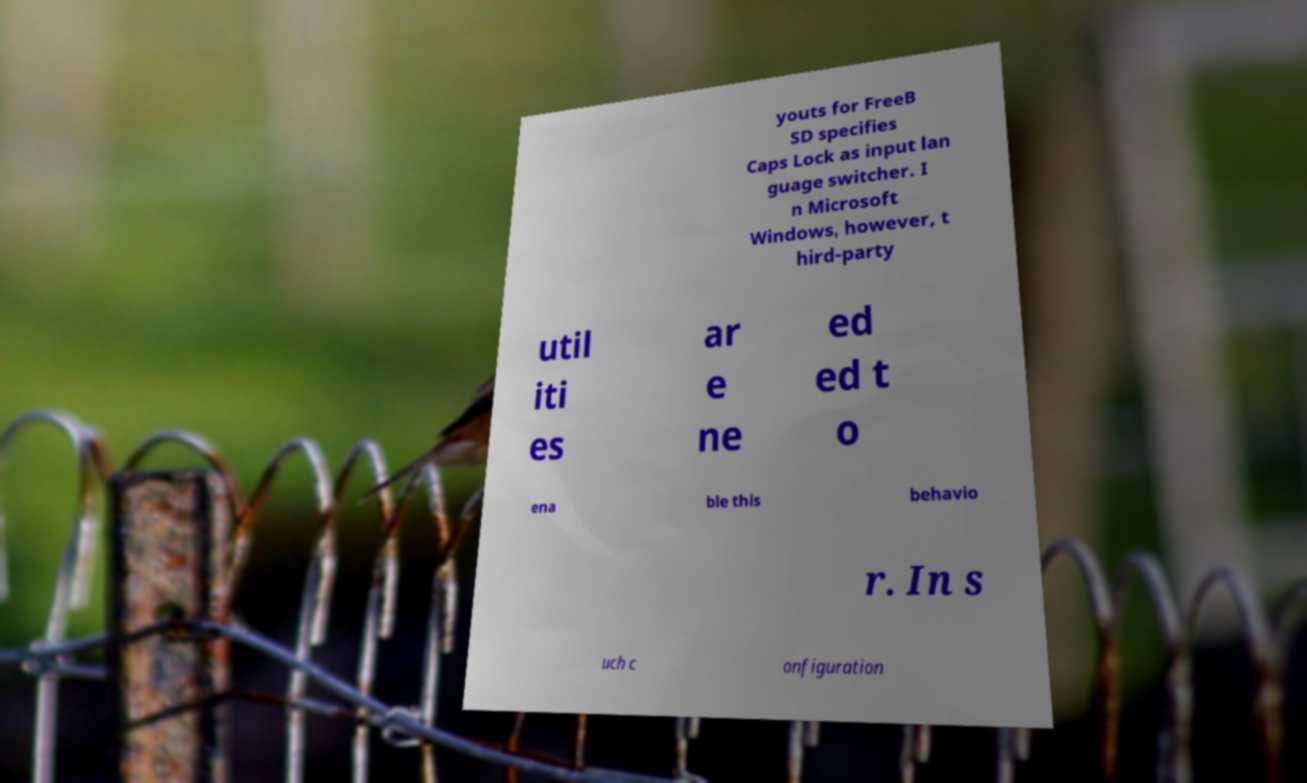Could you extract and type out the text from this image? youts for FreeB SD specifies Caps Lock as input lan guage switcher. I n Microsoft Windows, however, t hird-party util iti es ar e ne ed ed t o ena ble this behavio r. In s uch c onfiguration 